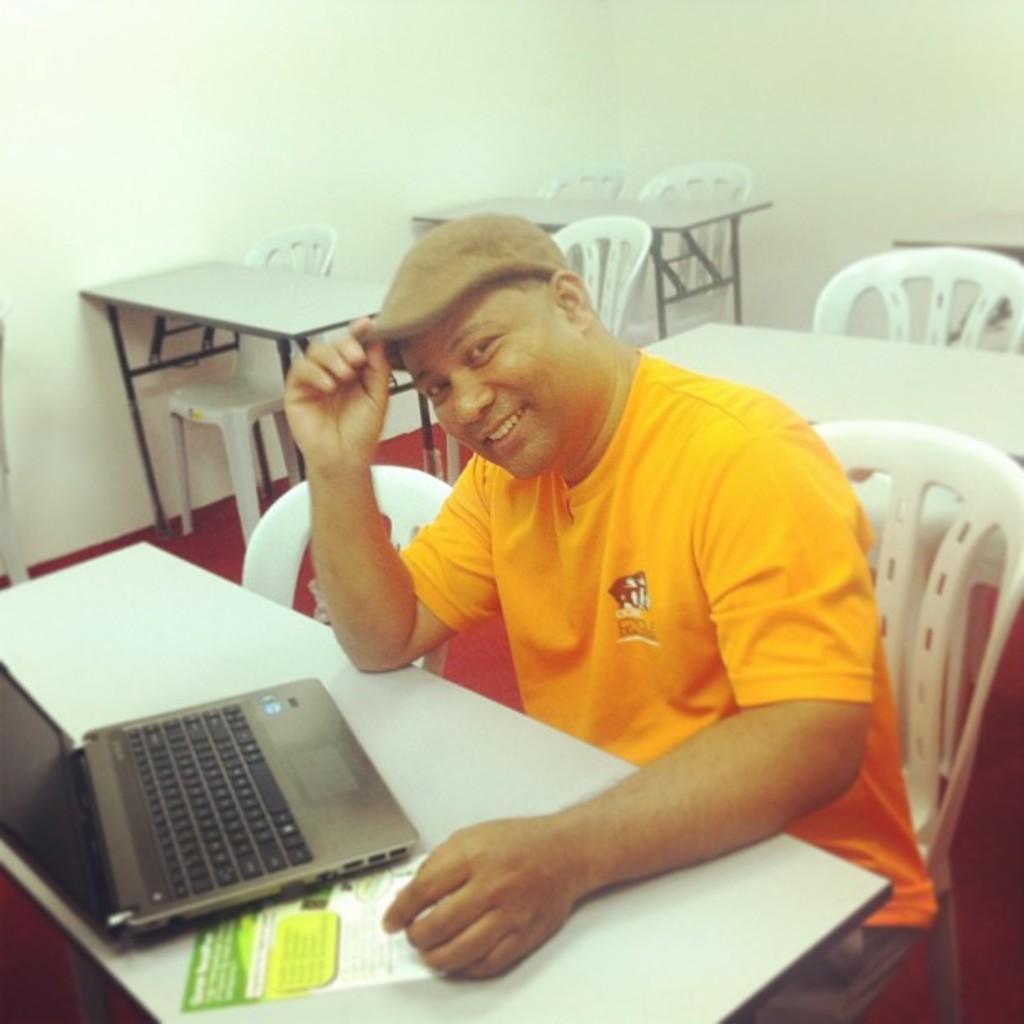Describe this image in one or two sentences. In this image there are chairs, table, wall, person and objects. On the table there is a laptop and poster. A person is sitting on a chair and holding his cap.  